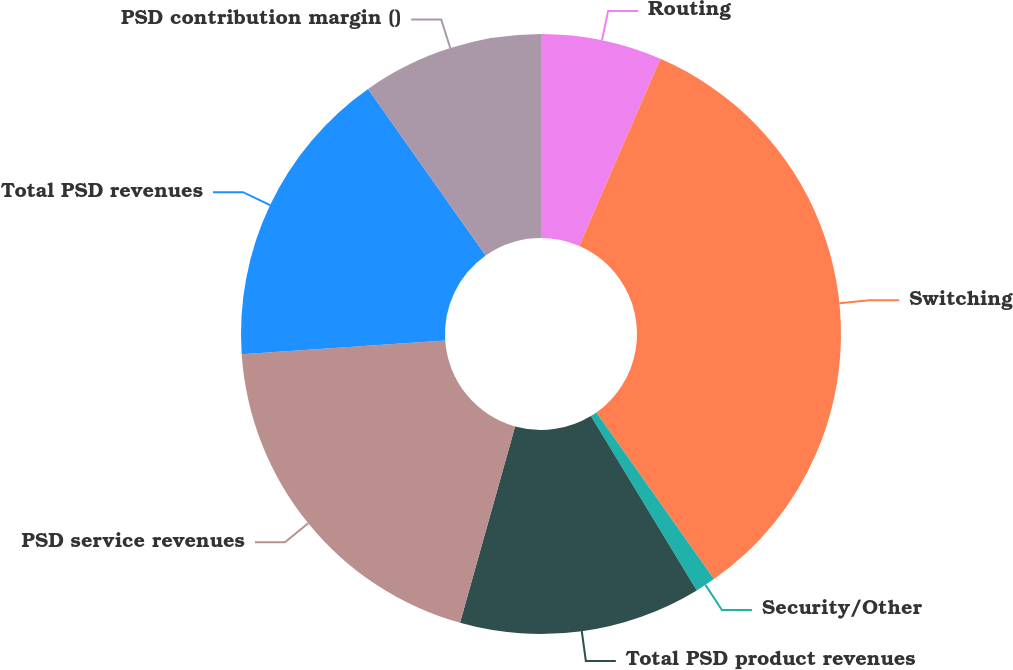Convert chart. <chart><loc_0><loc_0><loc_500><loc_500><pie_chart><fcel>Routing<fcel>Switching<fcel>Security/Other<fcel>Total PSD product revenues<fcel>PSD service revenues<fcel>Total PSD revenues<fcel>PSD contribution margin ()<nl><fcel>6.52%<fcel>33.7%<fcel>1.09%<fcel>13.04%<fcel>19.57%<fcel>16.3%<fcel>9.78%<nl></chart> 